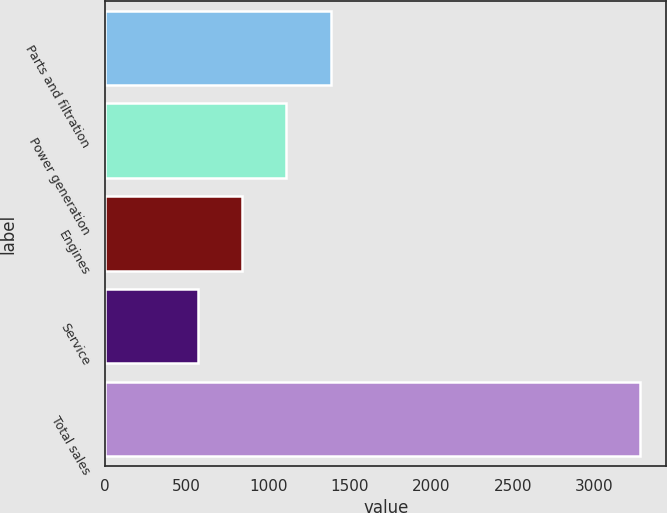Convert chart to OTSL. <chart><loc_0><loc_0><loc_500><loc_500><bar_chart><fcel>Parts and filtration<fcel>Power generation<fcel>Engines<fcel>Service<fcel>Total sales<nl><fcel>1382.1<fcel>1111.4<fcel>840.7<fcel>570<fcel>3277<nl></chart> 